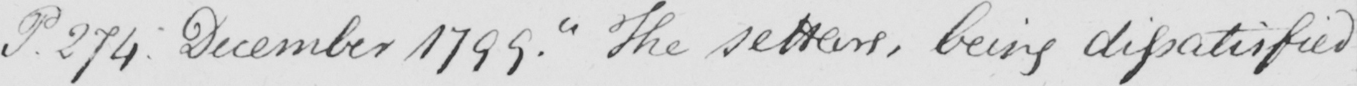What text is written in this handwritten line? P . 274 :  December 1799 .  " The settlers , being dissatisfied 